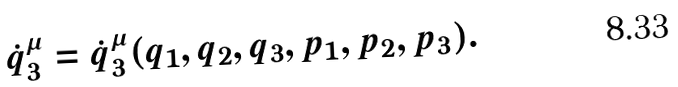<formula> <loc_0><loc_0><loc_500><loc_500>\dot { q } _ { 3 } ^ { \mu } = \dot { q } _ { 3 } ^ { \mu } ( q _ { 1 } , q _ { 2 } , q _ { 3 } , p _ { 1 } , p _ { 2 } , p _ { 3 } ) .</formula> 